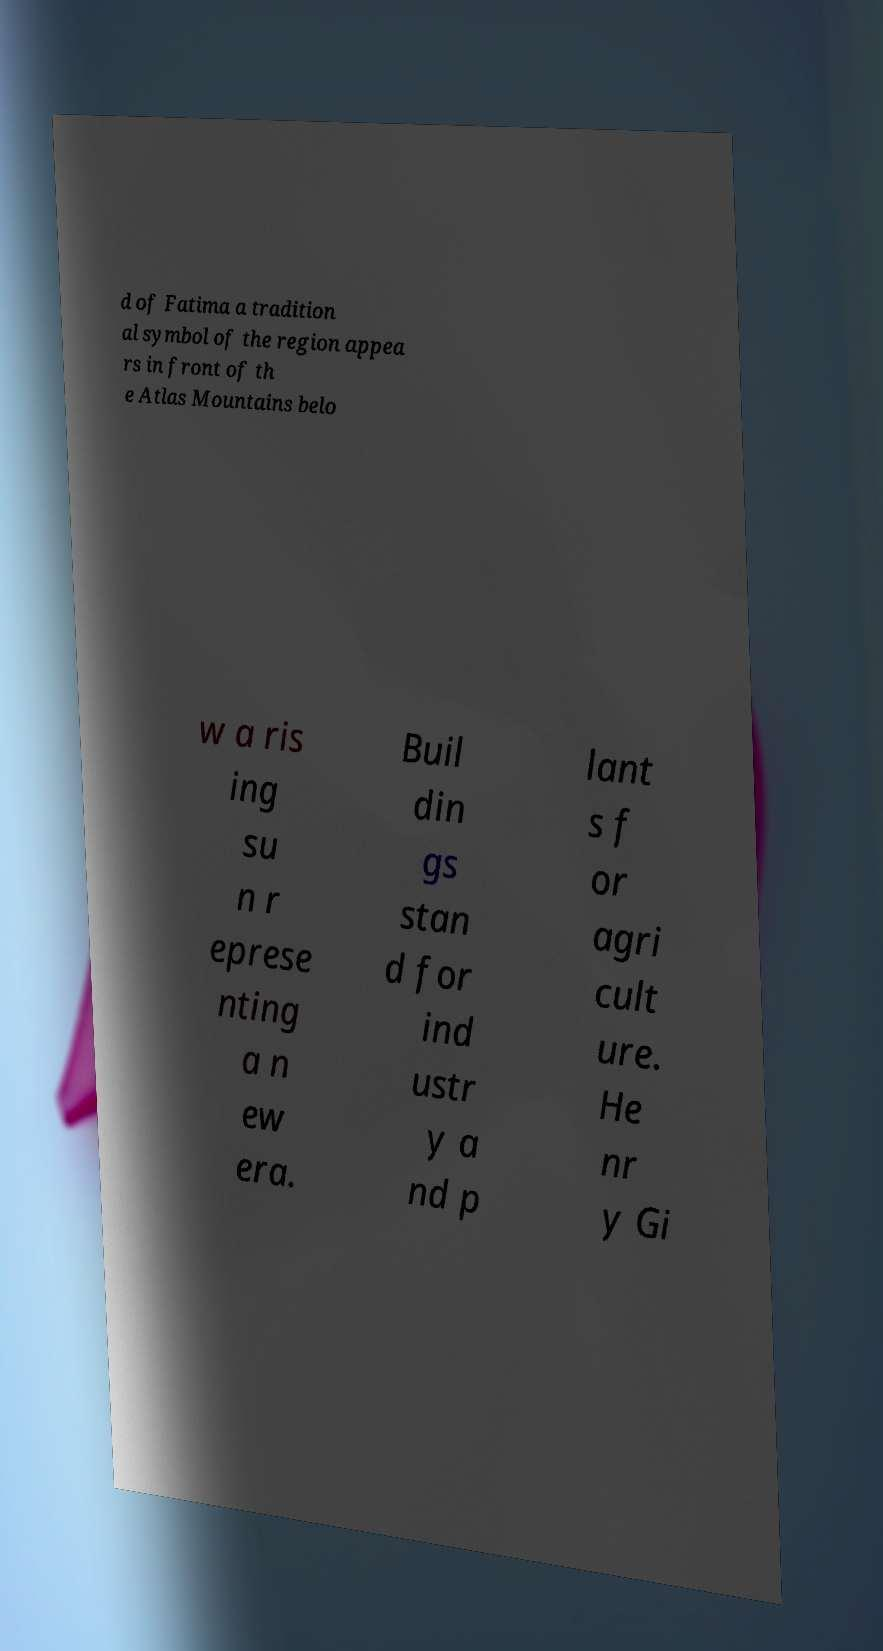Please read and relay the text visible in this image. What does it say? d of Fatima a tradition al symbol of the region appea rs in front of th e Atlas Mountains belo w a ris ing su n r eprese nting a n ew era. Buil din gs stan d for ind ustr y a nd p lant s f or agri cult ure. He nr y Gi 